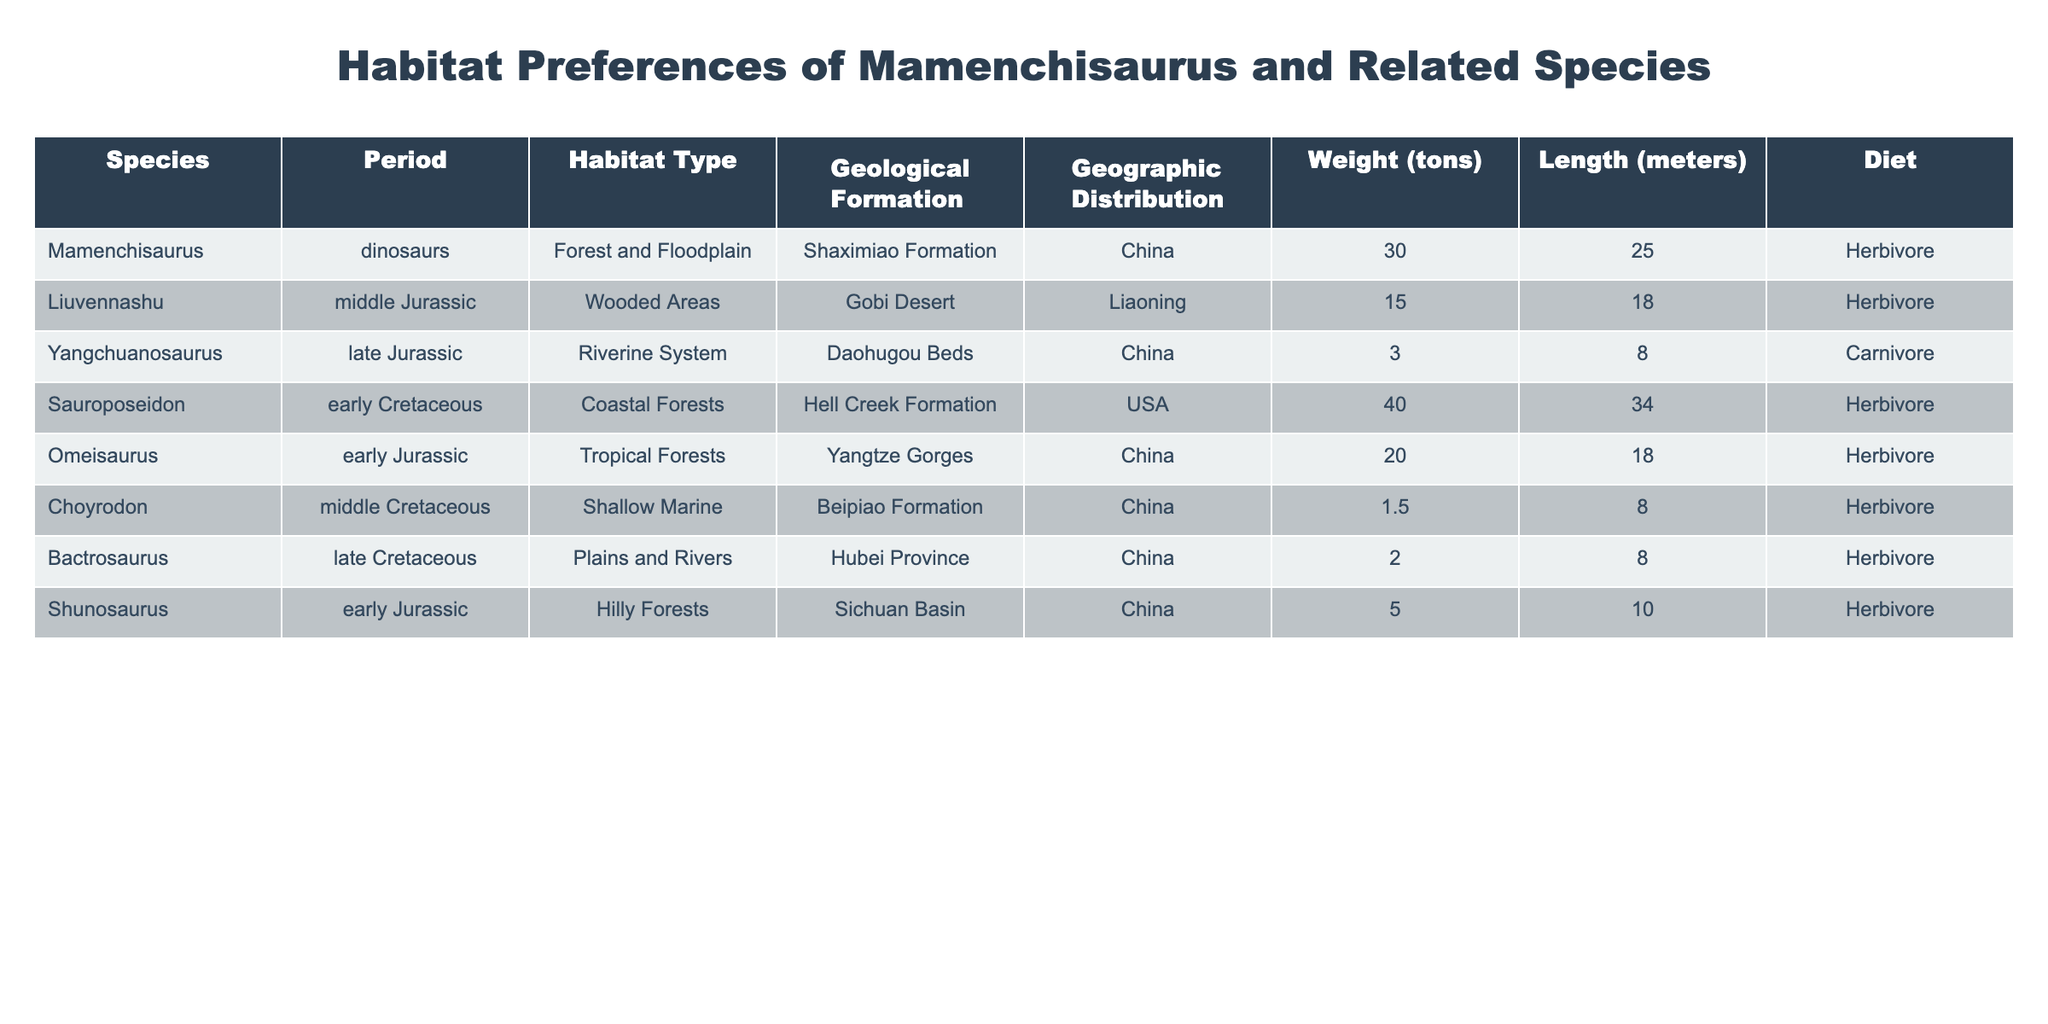What is the weight of Mamenchisaurus? From the table, we check the row corresponding to Mamenchisaurus, which shows a weight of 30 tons.
Answer: 30 tons Which species has the longest length? By examining the length values in the table, we see that Sauroposeidon is listed with a length of 34 meters, which is greater than all other species.
Answer: 34 meters Is Shunosaurus a carnivore? Looking at the diet information for Shunosaurus in the table, it indicates that Shunosaurus is a herbivore, not a carnivore.
Answer: No What is the average weight of the herbivores listed? The herbivores listed in the table are Mamenchisaurus (30), Liuvennashu (15), Sauroposeidon (40), Omeisaurus (20), Choyrodon (1.5), Bactrosaurus (2), and Shunosaurus (5). Adding their weights gives 30 + 15 + 40 + 20 + 1.5 + 2 + 5 = 113.5 tons. There are 7 herbivore species, so the average weight is 113.5 / 7 ≈ 16.21 tons.
Answer: Approximately 16.21 tons Which geological formation corresponds to Liuvennashu? In the table, under the Geological Formation column, when we find Liuvennashu, it is associated with the Gobi Desert.
Answer: Gobi Desert What is the total weight of all the species listed in the table? The weights shown in the table are: Mamenchisaurus (30), Liuvennashu (15), Yangchuanosaurus (3), Sauroposeidon (40), Omeisaurus (20), Choyrodon (1.5), Bactrosaurus (2), and Shunosaurus (5). The total weight is 30 + 15 + 3 + 40 + 20 + 1.5 + 2 + 5 = 116.5 tons.
Answer: 116.5 tons Is there any herbivore that resides in a coastal forest habitat? Checking the resident species in the Coastal Forests habitat, we find Sauroposeidon is an herbivore that fits this description.
Answer: Yes What is the difference in length between the longest and shortest species in the list? The longest species is Sauroposeidon at 34 meters, while the shortest species, Choyrodon, has a length of 8 meters. The difference is 34 - 8 = 26 meters.
Answer: 26 meters 